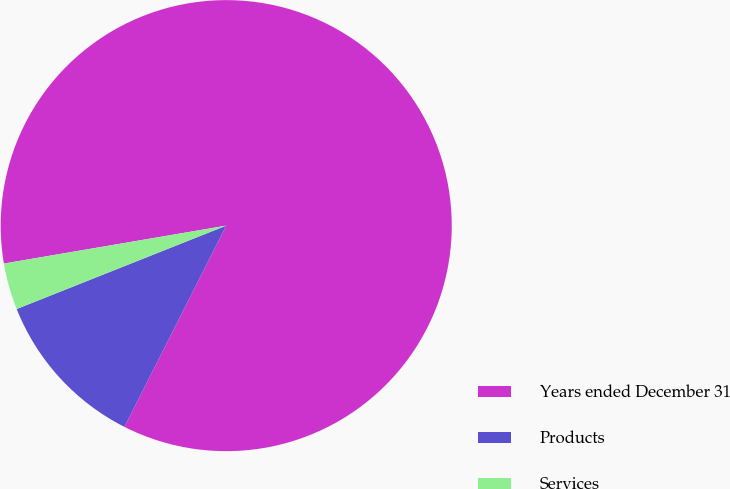Convert chart. <chart><loc_0><loc_0><loc_500><loc_500><pie_chart><fcel>Years ended December 31<fcel>Products<fcel>Services<nl><fcel>85.14%<fcel>11.52%<fcel>3.34%<nl></chart> 